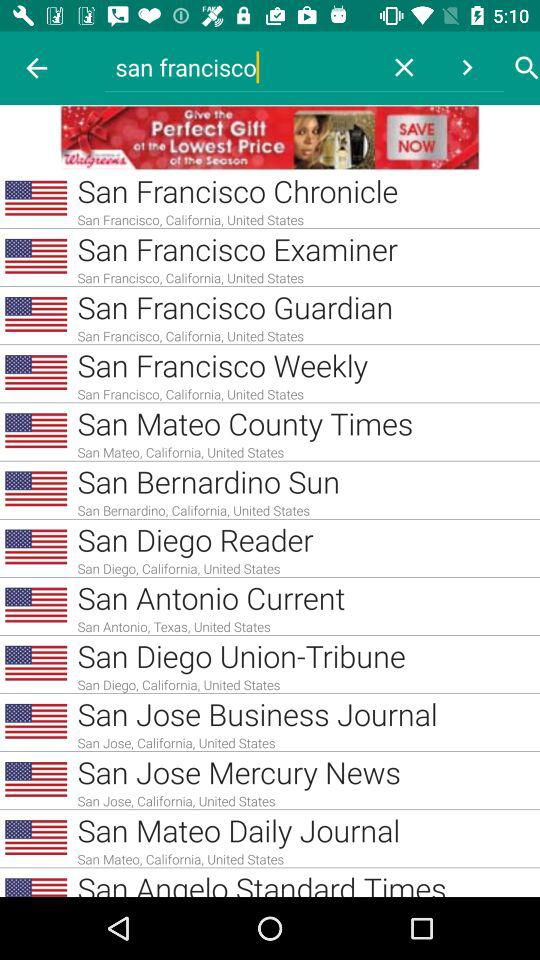How many items are from San Francisco?
Answer the question using a single word or phrase. 4 